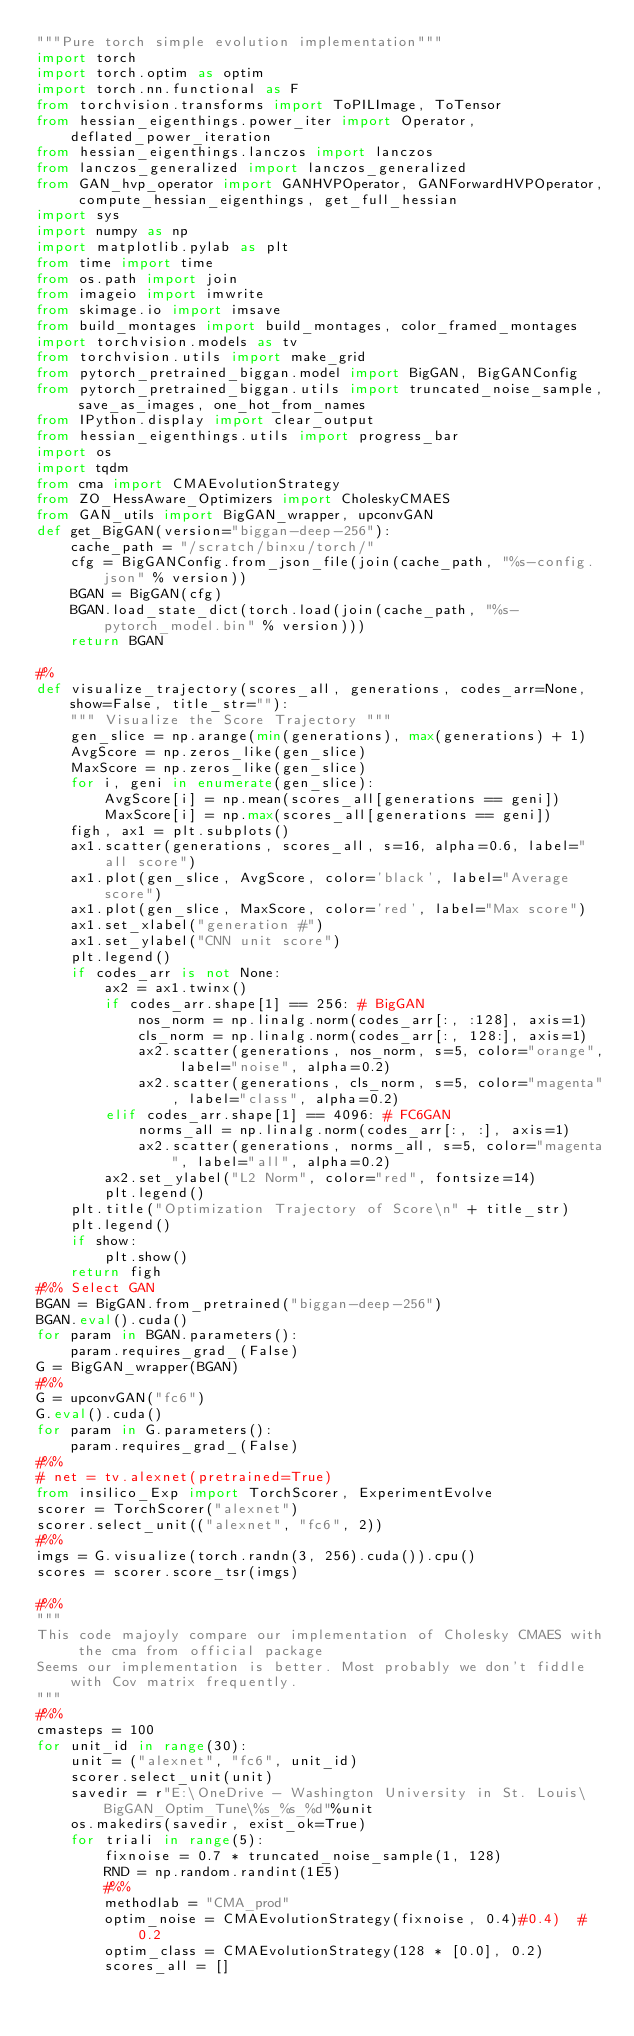<code> <loc_0><loc_0><loc_500><loc_500><_Python_>"""Pure torch simple evolution implementation"""
import torch
import torch.optim as optim
import torch.nn.functional as F
from torchvision.transforms import ToPILImage, ToTensor
from hessian_eigenthings.power_iter import Operator, deflated_power_iteration
from hessian_eigenthings.lanczos import lanczos
from lanczos_generalized import lanczos_generalized
from GAN_hvp_operator import GANHVPOperator, GANForwardHVPOperator, compute_hessian_eigenthings, get_full_hessian
import sys
import numpy as np
import matplotlib.pylab as plt
from time import time
from os.path import join
from imageio import imwrite
from skimage.io import imsave
from build_montages import build_montages, color_framed_montages
import torchvision.models as tv
from torchvision.utils import make_grid
from pytorch_pretrained_biggan.model import BigGAN, BigGANConfig
from pytorch_pretrained_biggan.utils import truncated_noise_sample, save_as_images, one_hot_from_names
from IPython.display import clear_output
from hessian_eigenthings.utils import progress_bar
import os
import tqdm
from cma import CMAEvolutionStrategy
from ZO_HessAware_Optimizers import CholeskyCMAES
from GAN_utils import BigGAN_wrapper, upconvGAN
def get_BigGAN(version="biggan-deep-256"):
    cache_path = "/scratch/binxu/torch/"
    cfg = BigGANConfig.from_json_file(join(cache_path, "%s-config.json" % version))
    BGAN = BigGAN(cfg)
    BGAN.load_state_dict(torch.load(join(cache_path, "%s-pytorch_model.bin" % version)))
    return BGAN

#%
def visualize_trajectory(scores_all, generations, codes_arr=None, show=False, title_str=""):
    """ Visualize the Score Trajectory """
    gen_slice = np.arange(min(generations), max(generations) + 1)
    AvgScore = np.zeros_like(gen_slice)
    MaxScore = np.zeros_like(gen_slice)
    for i, geni in enumerate(gen_slice):
        AvgScore[i] = np.mean(scores_all[generations == geni])
        MaxScore[i] = np.max(scores_all[generations == geni])
    figh, ax1 = plt.subplots()
    ax1.scatter(generations, scores_all, s=16, alpha=0.6, label="all score")
    ax1.plot(gen_slice, AvgScore, color='black', label="Average score")
    ax1.plot(gen_slice, MaxScore, color='red', label="Max score")
    ax1.set_xlabel("generation #")
    ax1.set_ylabel("CNN unit score")
    plt.legend()
    if codes_arr is not None:
        ax2 = ax1.twinx()
        if codes_arr.shape[1] == 256: # BigGAN
            nos_norm = np.linalg.norm(codes_arr[:, :128], axis=1)
            cls_norm = np.linalg.norm(codes_arr[:, 128:], axis=1)
            ax2.scatter(generations, nos_norm, s=5, color="orange", label="noise", alpha=0.2)
            ax2.scatter(generations, cls_norm, s=5, color="magenta", label="class", alpha=0.2)
        elif codes_arr.shape[1] == 4096: # FC6GAN
            norms_all = np.linalg.norm(codes_arr[:, :], axis=1)
            ax2.scatter(generations, norms_all, s=5, color="magenta", label="all", alpha=0.2)
        ax2.set_ylabel("L2 Norm", color="red", fontsize=14)
        plt.legend()
    plt.title("Optimization Trajectory of Score\n" + title_str)
    plt.legend()
    if show:
        plt.show()
    return figh
#%% Select GAN
BGAN = BigGAN.from_pretrained("biggan-deep-256")
BGAN.eval().cuda()
for param in BGAN.parameters():
    param.requires_grad_(False)
G = BigGAN_wrapper(BGAN)
#%%
G = upconvGAN("fc6")
G.eval().cuda()
for param in G.parameters():
    param.requires_grad_(False)
#%%
# net = tv.alexnet(pretrained=True)
from insilico_Exp import TorchScorer, ExperimentEvolve
scorer = TorchScorer("alexnet")
scorer.select_unit(("alexnet", "fc6", 2))
#%%
imgs = G.visualize(torch.randn(3, 256).cuda()).cpu()
scores = scorer.score_tsr(imgs)

#%%
"""
This code majoyly compare our implementation of Cholesky CMAES with the cma from official package
Seems our implementation is better. Most probably we don't fiddle with Cov matrix frequently.
"""
#%%
cmasteps = 100
for unit_id in range(30):
    unit = ("alexnet", "fc6", unit_id)
    scorer.select_unit(unit)
    savedir = r"E:\OneDrive - Washington University in St. Louis\BigGAN_Optim_Tune\%s_%s_%d"%unit
    os.makedirs(savedir, exist_ok=True)
    for triali in range(5):
        fixnoise = 0.7 * truncated_noise_sample(1, 128)
        RND = np.random.randint(1E5)
        #%%
        methodlab = "CMA_prod"
        optim_noise = CMAEvolutionStrategy(fixnoise, 0.4)#0.4)  # 0.2
        optim_class = CMAEvolutionStrategy(128 * [0.0], 0.2)
        scores_all = []</code> 